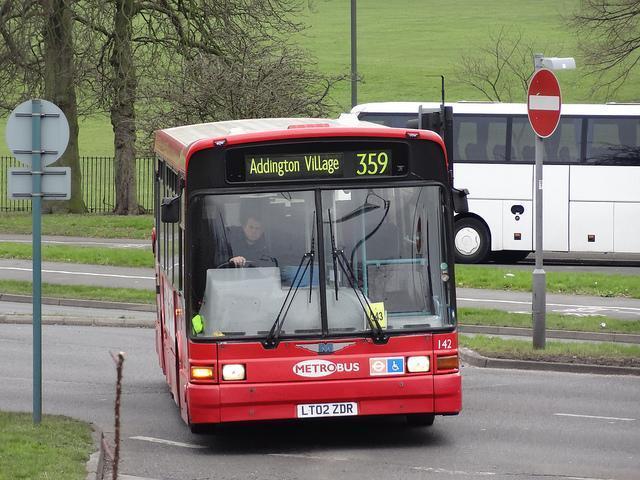How many buses are visible?
Give a very brief answer. 2. How many cars are in the intersection?
Give a very brief answer. 0. 